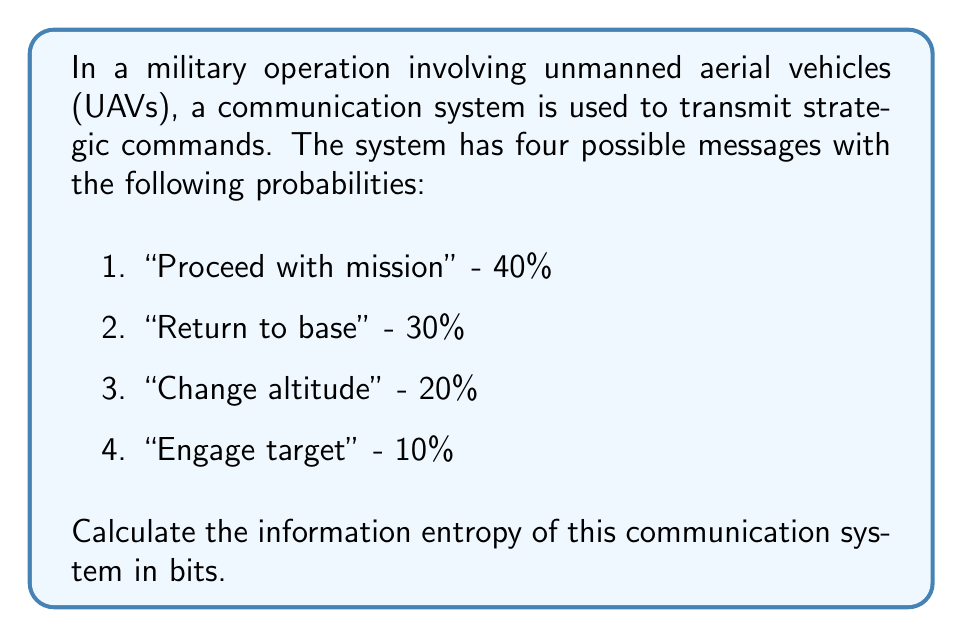Could you help me with this problem? To calculate the information entropy of this communication system, we'll use Shannon's entropy formula:

$$H = -\sum_{i=1}^{n} p_i \log_2(p_i)$$

Where:
- $H$ is the entropy in bits
- $p_i$ is the probability of each message
- $n$ is the number of possible messages

Let's calculate for each message:

1. $p_1 = 0.4$
   $-0.4 \log_2(0.4) = 0.528321$

2. $p_2 = 0.3$
   $-0.3 \log_2(0.3) = 0.521126$

3. $p_3 = 0.2$
   $-0.2 \log_2(0.2) = 0.464386$

4. $p_4 = 0.1$
   $-0.1 \log_2(0.1) = 0.332193$

Now, we sum these values:

$$H = 0.528321 + 0.521126 + 0.464386 + 0.332193 = 1.846026$$

Therefore, the information entropy of this communication system is approximately 1.846026 bits.
Answer: $H \approx 1.846$ bits 